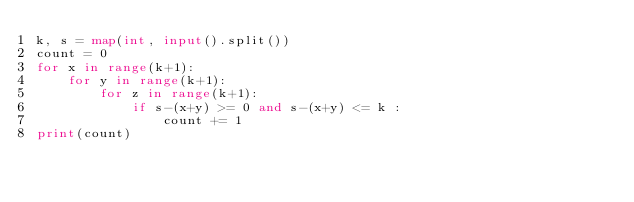Convert code to text. <code><loc_0><loc_0><loc_500><loc_500><_Python_>k, s = map(int, input().split())
count = 0
for x in range(k+1):
    for y in range(k+1):
        for z in range(k+1):
            if s-(x+y) >= 0 and s-(x+y) <= k :
                count += 1
print(count)
</code> 